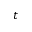<formula> <loc_0><loc_0><loc_500><loc_500>t</formula> 